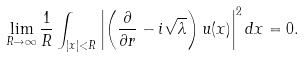<formula> <loc_0><loc_0><loc_500><loc_500>\lim _ { R \to \infty } \frac { 1 } { R } \int _ { | x | < R } \left | \left ( \frac { \partial } { \partial r } - i \sqrt { \lambda } \right ) u ( x ) \right | ^ { 2 } d x = 0 .</formula> 